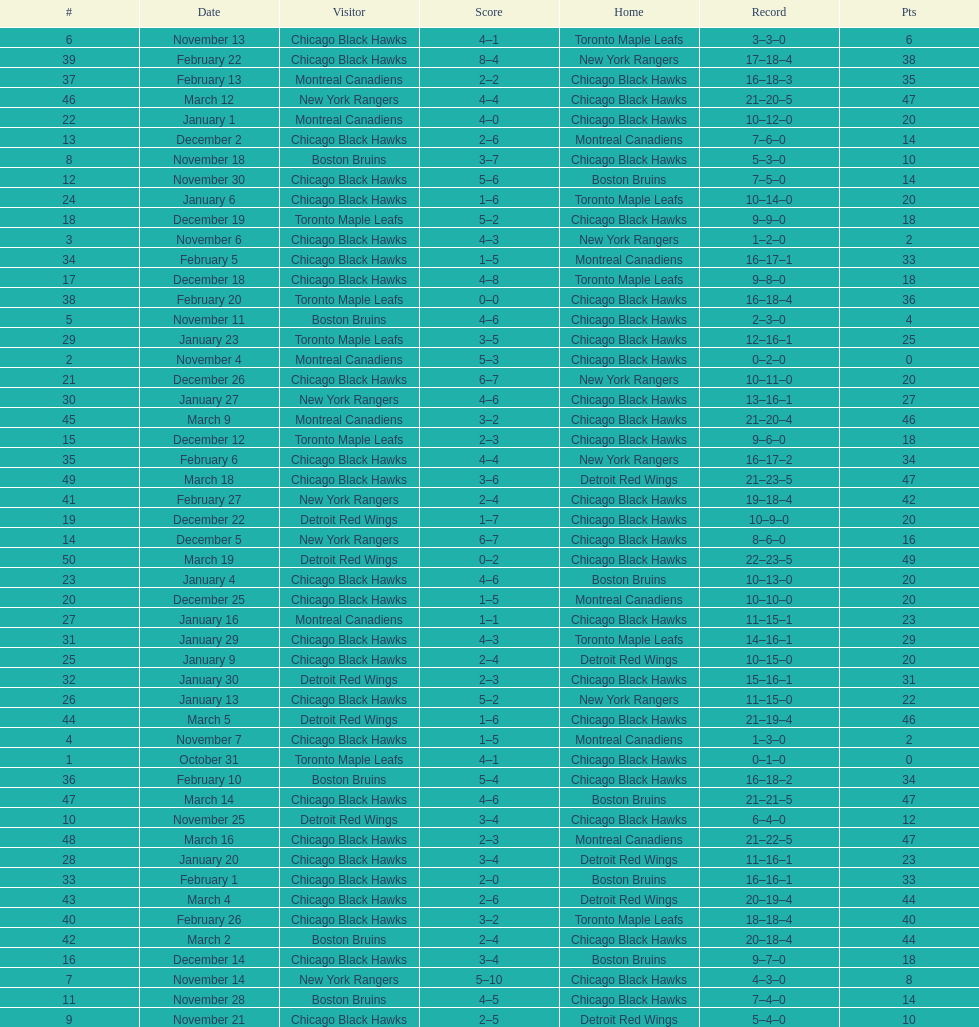On december 14 was the home team the chicago black hawks or the boston bruins? Boston Bruins. 